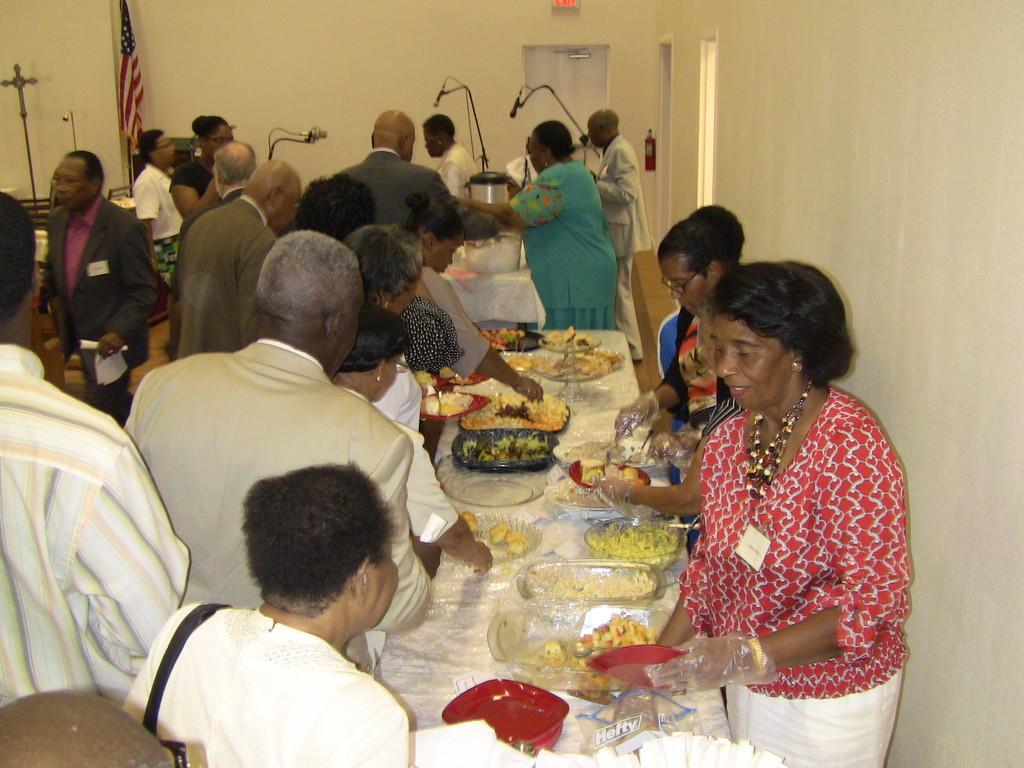How would you summarize this image in a sentence or two? In the foreground I can see a group of people on the floor and tables on which plates, bowls and food items are there. In the background I can see a wall, door, flag, mikes and so on. This image is taken may be in a hall. 